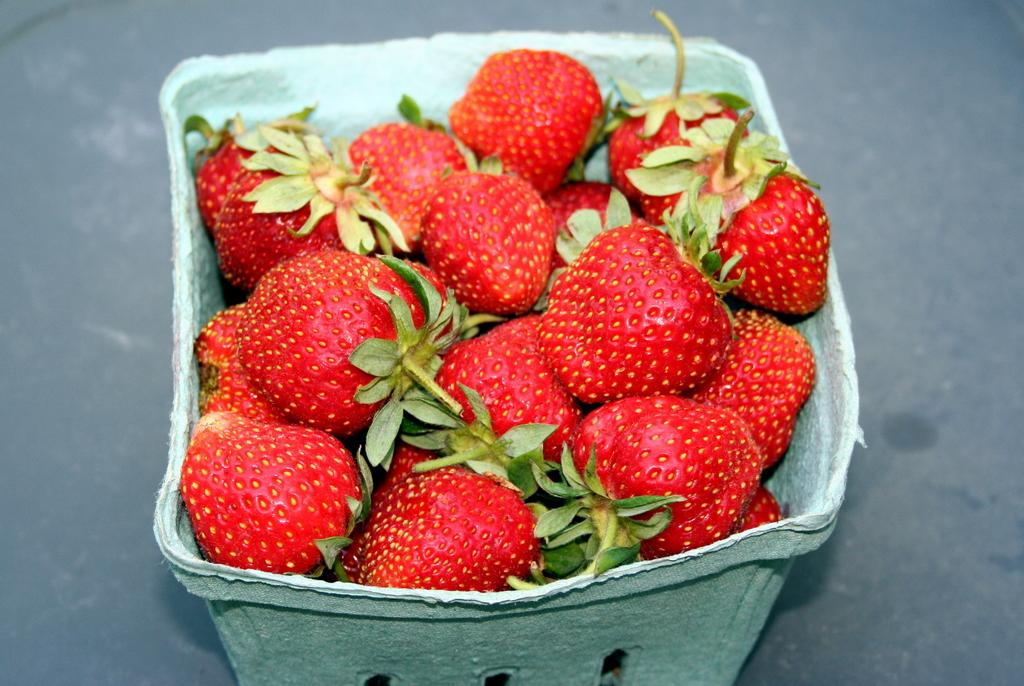What is in the bowl that is visible in the image? The bowl is full of strawberries. Can you describe the contents of the bowl in more detail? The bowl contains ripe, red strawberries. Is there any other information about the setting of the image that can be inferred from the facts? Although not explicitly mentioned, the image likely depicts a table, as it is a common place to find a bowl of fruit. What type of farmer is shown working in the downtown area in the image? There is no farmer or downtown area depicted in the image; it only shows a bowl of strawberries. 